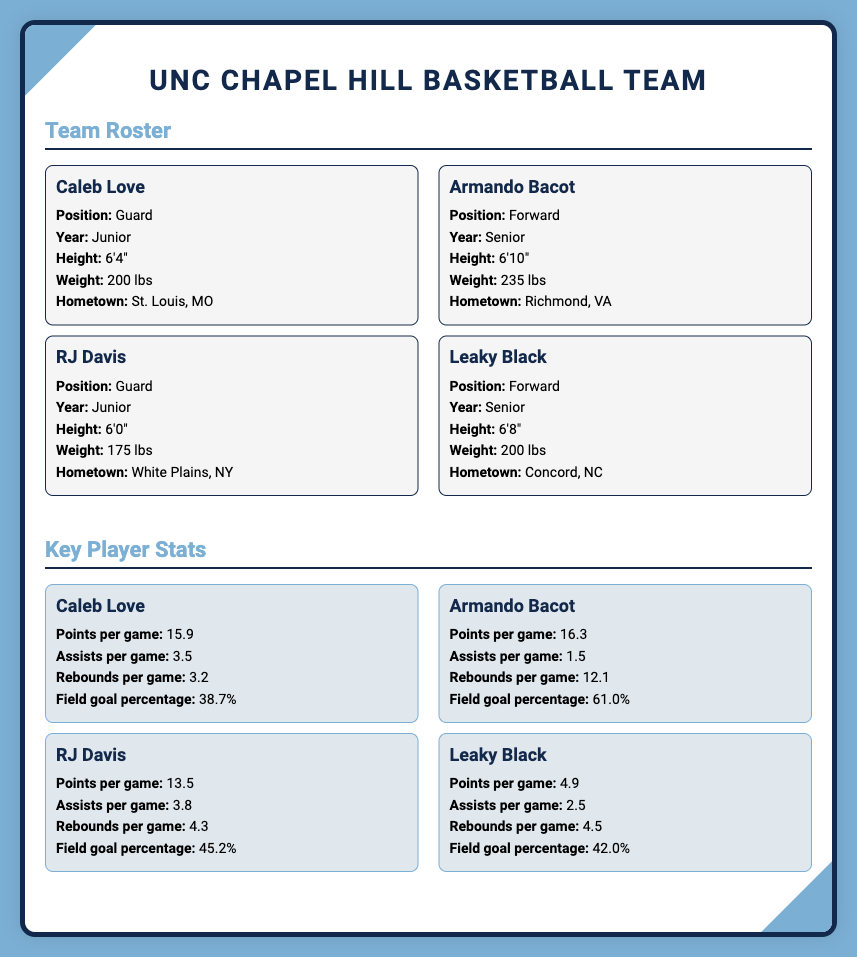What position does Caleb Love play? The document specifies that Caleb Love plays as a Guard.
Answer: Guard How many rebounds per game does Armando Bacot average? The document states that Armando Bacot averages 12.1 rebounds per game.
Answer: 12.1 What is RJ Davis's field goal percentage? The document indicates that RJ Davis has a field goal percentage of 45.2%.
Answer: 45.2% Which player is from Concord, NC? The document lists Leaky Black as the player from Concord, NC.
Answer: Leaky Black What is the weight of Armando Bacot? The document mentions that Armando Bacot weighs 235 lbs.
Answer: 235 lbs Which player has the highest points per game? Based on the stats provided, Armando Bacot has the highest points per game at 16.3.
Answer: Armando Bacot How many years has Leaky Black played? Leaky Black is listed as a Senior, indicating he has played for four years.
Answer: Senior What is the common height for the forwards in the roster? Both Armando Bacot and Leaky Black are forwards, with heights of 6'10" and 6'8", respectively, averaging 6'9".
Answer: 6'9" Name one stat that shows Caleb Love's performance. The document displays Caleb Love's points per game as one of his performance stats, which is 15.9.
Answer: 15.9 